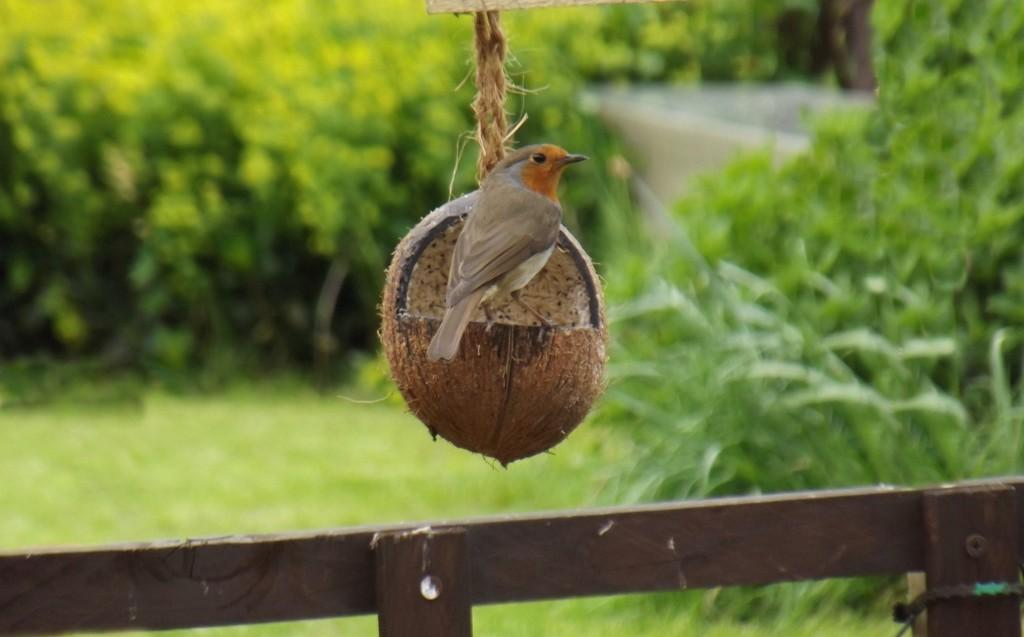What animal can be seen in the image? There is a bird in the image. What is the bird standing on? The bird is standing on a coconut shell. How is the coconut shell attached or supported? The coconut shell is tied to a rope. What type of structure is visible in the image? There is a wooden fence in the image. What type of vegetation is present in the background of the image? There are plants in the background of the image. What is the ground like where the plants are located? The plants are on a grassland. What type of tree can be seen in the image? There is no tree present in the image. 